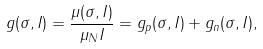Convert formula to latex. <formula><loc_0><loc_0><loc_500><loc_500>g ( \sigma , I ) = \frac { \mu ( \sigma , I ) } { \mu _ { N } I } = g _ { p } ( \sigma , I ) + g _ { n } ( \sigma , I ) ,</formula> 